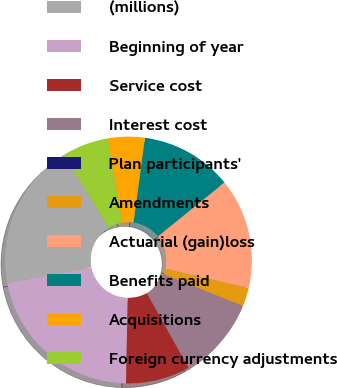<chart> <loc_0><loc_0><loc_500><loc_500><pie_chart><fcel>(millions)<fcel>Beginning of year<fcel>Service cost<fcel>Interest cost<fcel>Plan participants'<fcel>Amendments<fcel>Actuarial (gain)loss<fcel>Benefits paid<fcel>Acquisitions<fcel>Foreign currency adjustments<nl><fcel>19.27%<fcel>21.68%<fcel>8.43%<fcel>10.84%<fcel>0.0%<fcel>2.41%<fcel>14.46%<fcel>12.05%<fcel>4.82%<fcel>6.03%<nl></chart> 